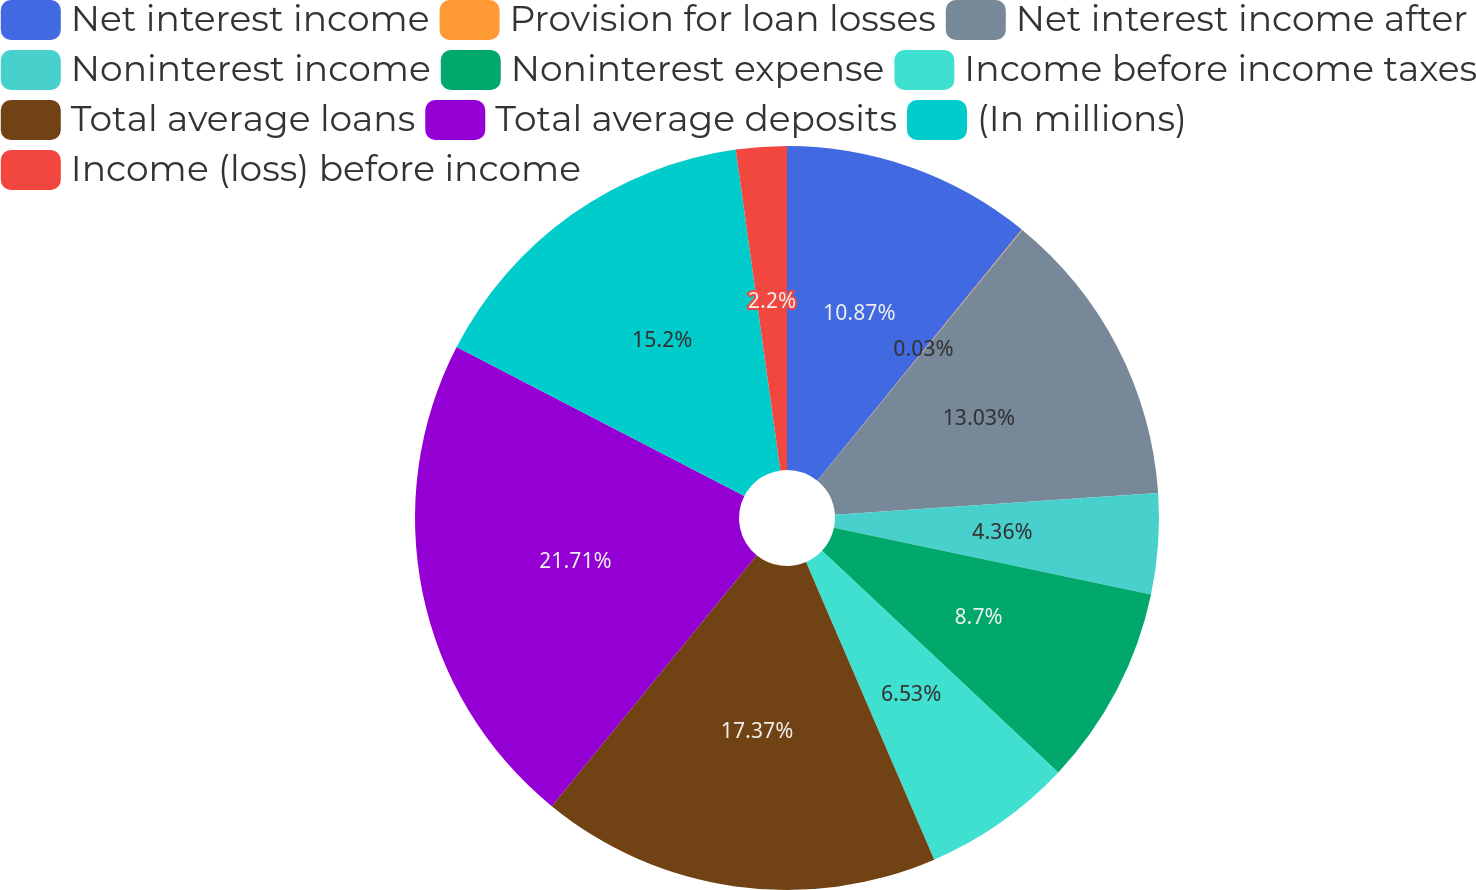<chart> <loc_0><loc_0><loc_500><loc_500><pie_chart><fcel>Net interest income<fcel>Provision for loan losses<fcel>Net interest income after<fcel>Noninterest income<fcel>Noninterest expense<fcel>Income before income taxes<fcel>Total average loans<fcel>Total average deposits<fcel>(In millions)<fcel>Income (loss) before income<nl><fcel>10.87%<fcel>0.03%<fcel>13.03%<fcel>4.36%<fcel>8.7%<fcel>6.53%<fcel>17.37%<fcel>21.7%<fcel>15.2%<fcel>2.2%<nl></chart> 